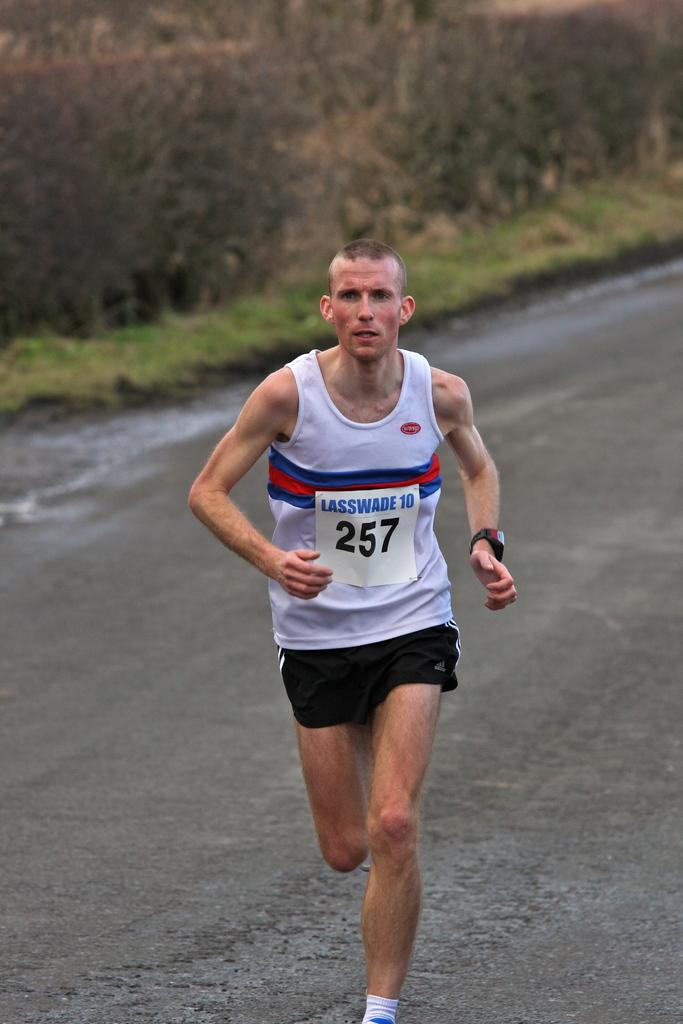<image>
Offer a succinct explanation of the picture presented. A man runs with the number 257 on his shirt. 